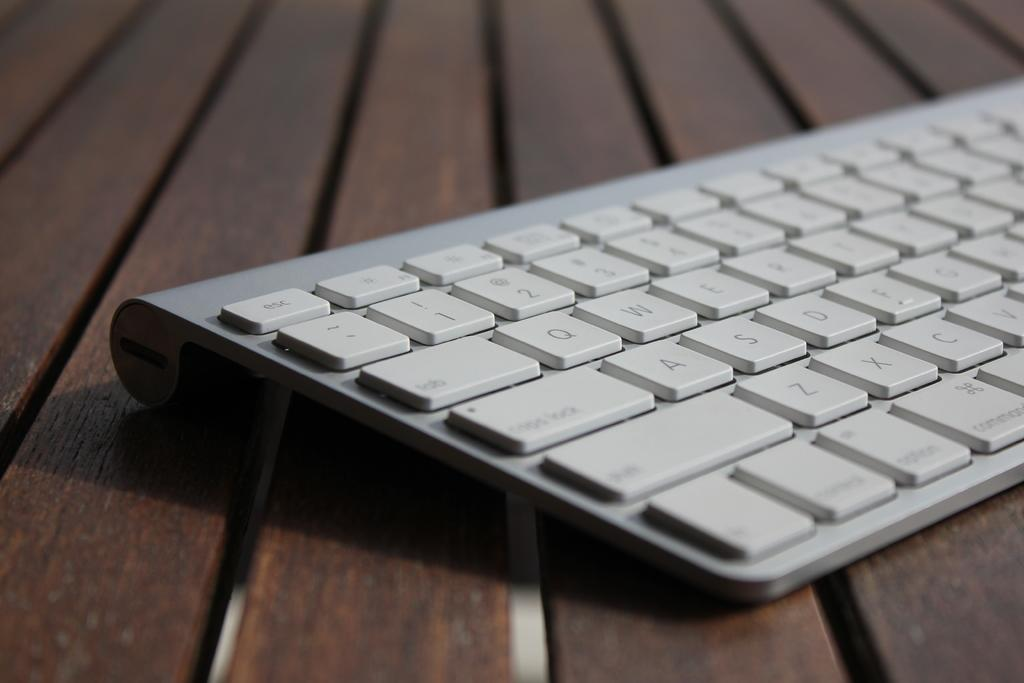<image>
Create a compact narrative representing the image presented. A partial view grey computer keyboard with ESC key visible with some letters 